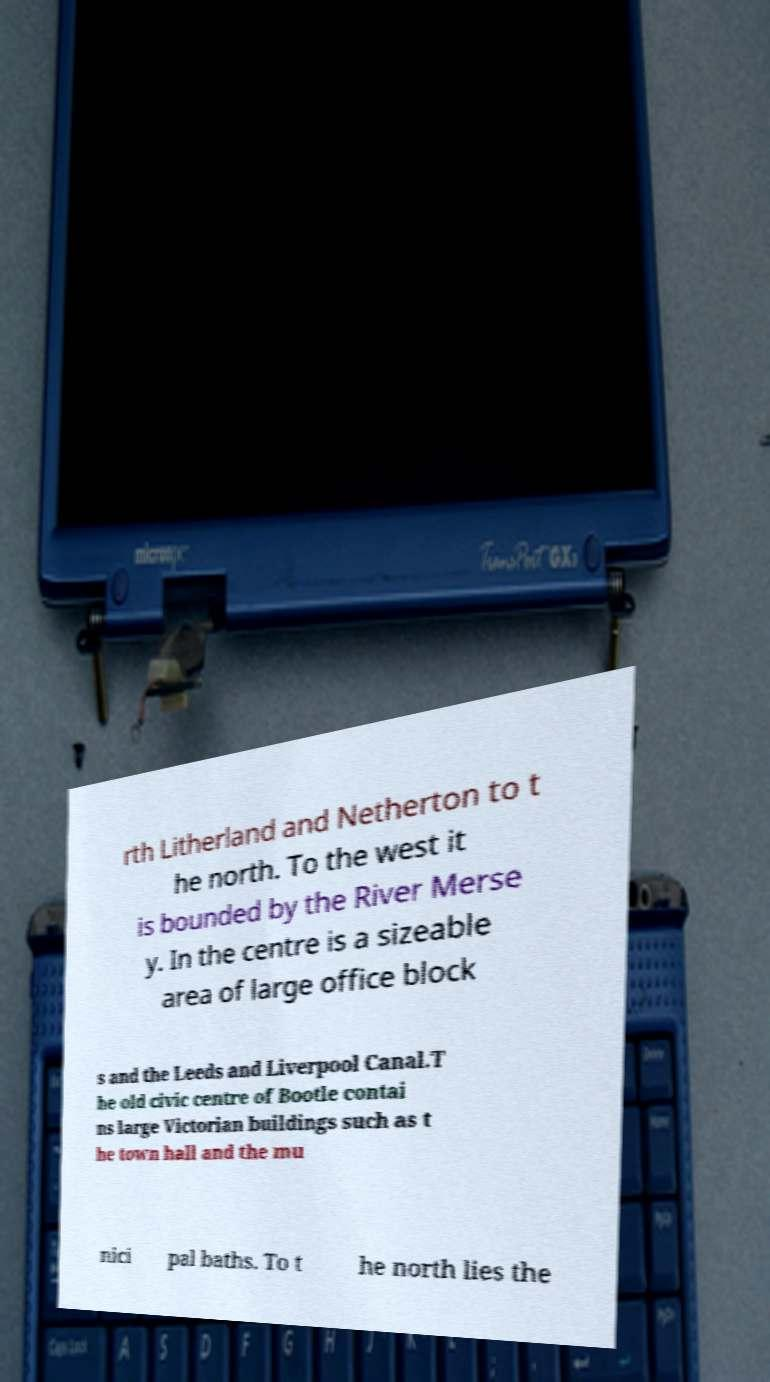Could you extract and type out the text from this image? rth Litherland and Netherton to t he north. To the west it is bounded by the River Merse y. In the centre is a sizeable area of large office block s and the Leeds and Liverpool Canal.T he old civic centre of Bootle contai ns large Victorian buildings such as t he town hall and the mu nici pal baths. To t he north lies the 